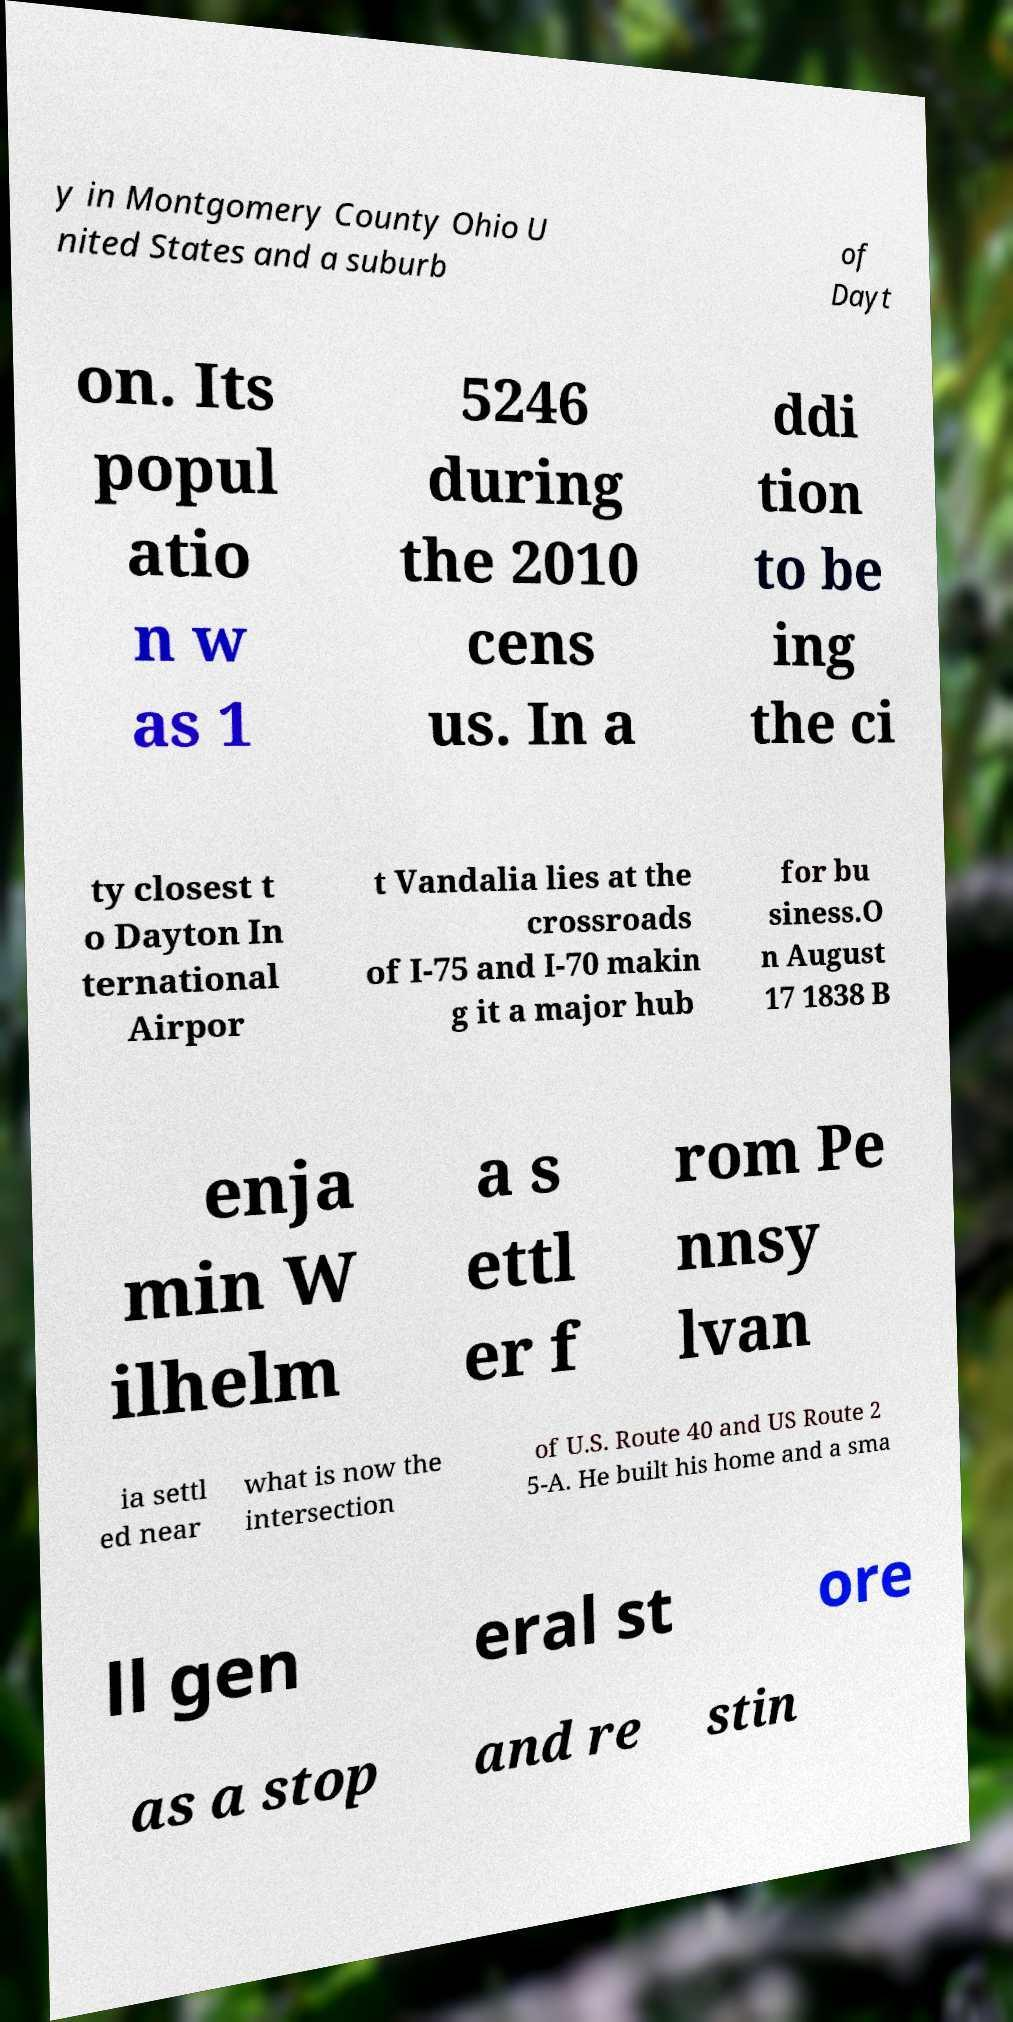Can you read and provide the text displayed in the image?This photo seems to have some interesting text. Can you extract and type it out for me? y in Montgomery County Ohio U nited States and a suburb of Dayt on. Its popul atio n w as 1 5246 during the 2010 cens us. In a ddi tion to be ing the ci ty closest t o Dayton In ternational Airpor t Vandalia lies at the crossroads of I-75 and I-70 makin g it a major hub for bu siness.O n August 17 1838 B enja min W ilhelm a s ettl er f rom Pe nnsy lvan ia settl ed near what is now the intersection of U.S. Route 40 and US Route 2 5-A. He built his home and a sma ll gen eral st ore as a stop and re stin 